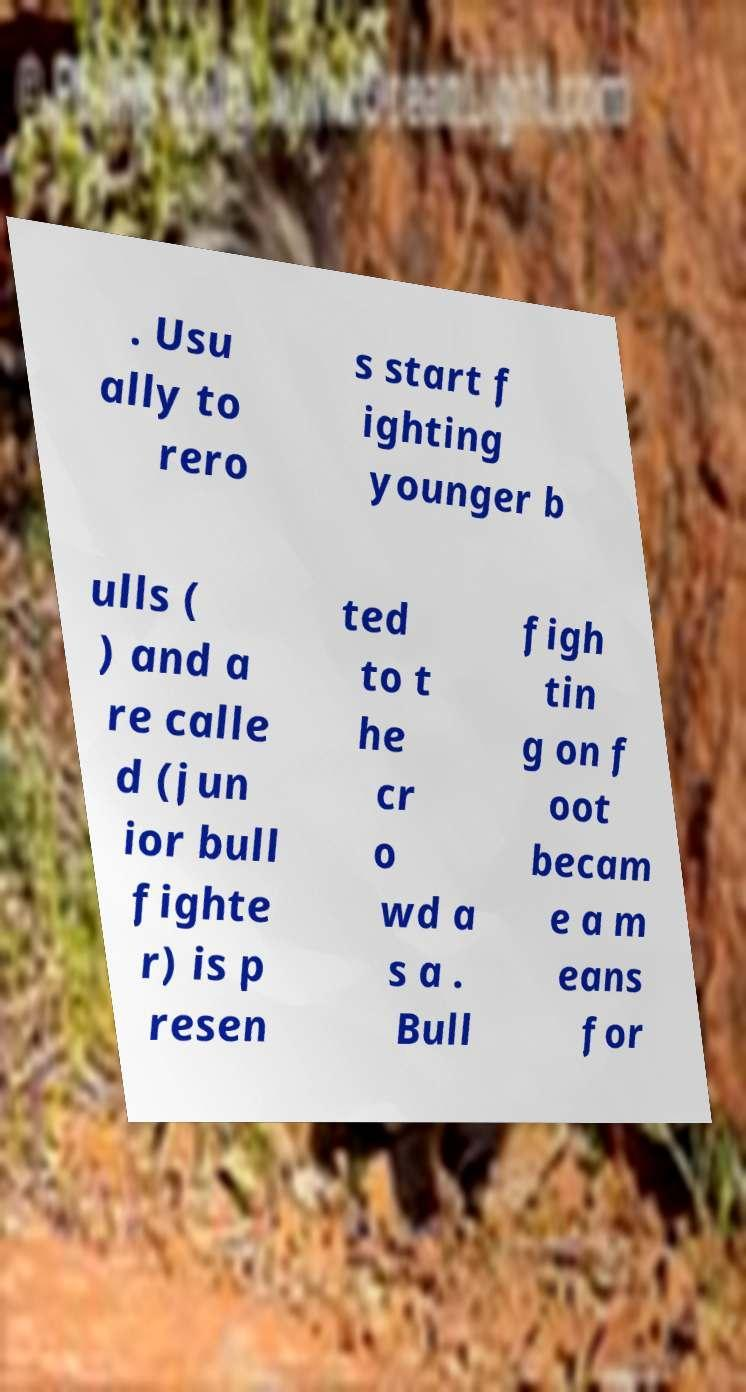Please read and relay the text visible in this image. What does it say? . Usu ally to rero s start f ighting younger b ulls ( ) and a re calle d (jun ior bull fighte r) is p resen ted to t he cr o wd a s a . Bull figh tin g on f oot becam e a m eans for 